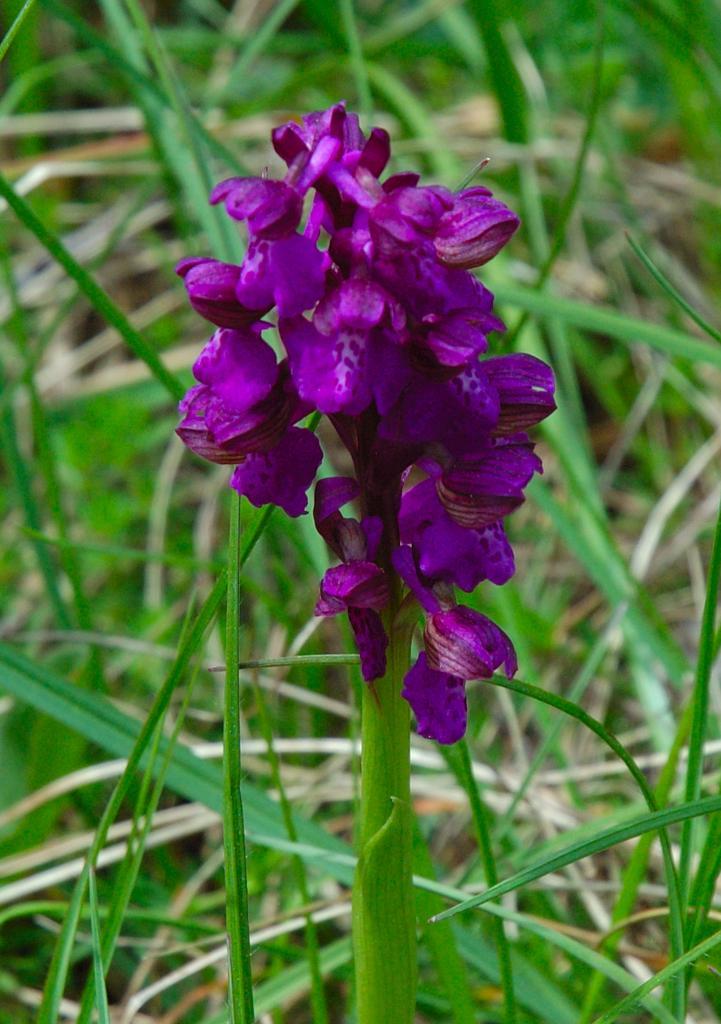Describe this image in one or two sentences. This image is taken outdoors. In the background there's grass on the ground. In the middle of the image there is a plant with beautiful purple flowers on it. 